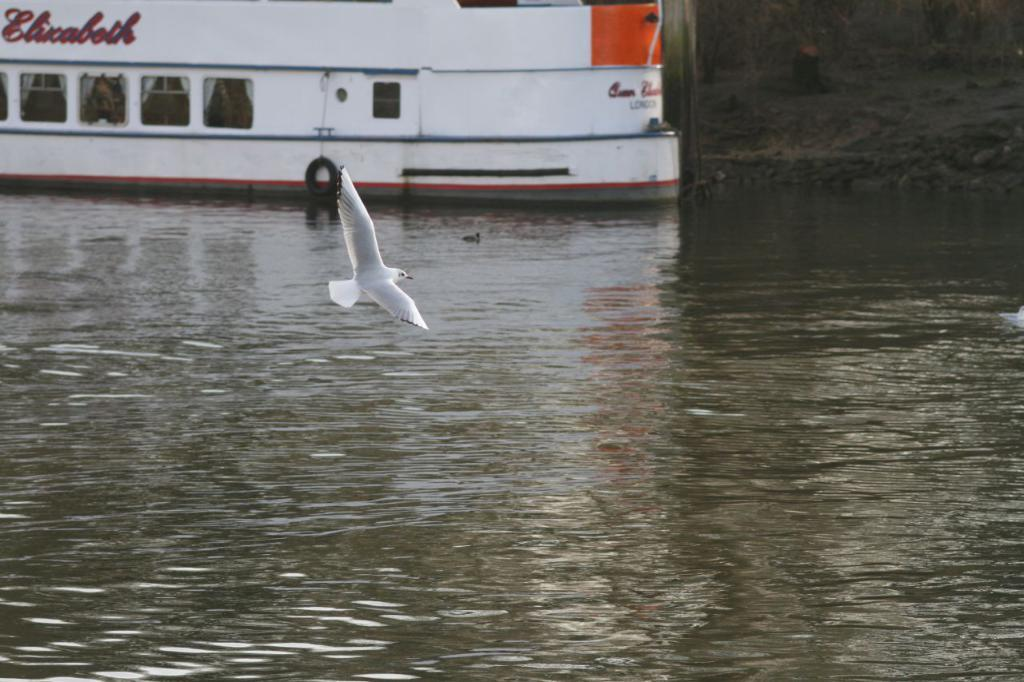What type of animal can be seen in the image? There is a bird in the image. What is the bird doing in the image? The bird is swimming above a lake. What can be seen in the background of the image? There is a ship visible in the background of the image. What type of prison can be seen in the image? There is no prison present in the image; it features a bird swimming above a lake and a ship in the background. 